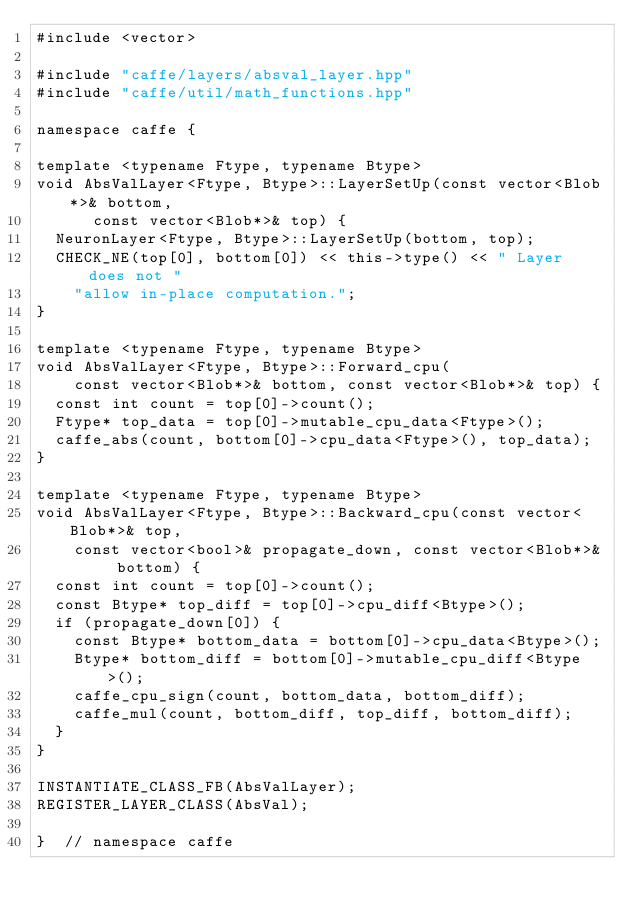Convert code to text. <code><loc_0><loc_0><loc_500><loc_500><_C++_>#include <vector>

#include "caffe/layers/absval_layer.hpp"
#include "caffe/util/math_functions.hpp"

namespace caffe {

template <typename Ftype, typename Btype>
void AbsValLayer<Ftype, Btype>::LayerSetUp(const vector<Blob*>& bottom,
      const vector<Blob*>& top) {
  NeuronLayer<Ftype, Btype>::LayerSetUp(bottom, top);
  CHECK_NE(top[0], bottom[0]) << this->type() << " Layer does not "
    "allow in-place computation.";
}

template <typename Ftype, typename Btype>
void AbsValLayer<Ftype, Btype>::Forward_cpu(
    const vector<Blob*>& bottom, const vector<Blob*>& top) {
  const int count = top[0]->count();
  Ftype* top_data = top[0]->mutable_cpu_data<Ftype>();
  caffe_abs(count, bottom[0]->cpu_data<Ftype>(), top_data);
}

template <typename Ftype, typename Btype>
void AbsValLayer<Ftype, Btype>::Backward_cpu(const vector<Blob*>& top,
    const vector<bool>& propagate_down, const vector<Blob*>& bottom) {
  const int count = top[0]->count();
  const Btype* top_diff = top[0]->cpu_diff<Btype>();
  if (propagate_down[0]) {
    const Btype* bottom_data = bottom[0]->cpu_data<Btype>();
    Btype* bottom_diff = bottom[0]->mutable_cpu_diff<Btype>();
    caffe_cpu_sign(count, bottom_data, bottom_diff);
    caffe_mul(count, bottom_diff, top_diff, bottom_diff);
  }
}

INSTANTIATE_CLASS_FB(AbsValLayer);
REGISTER_LAYER_CLASS(AbsVal);

}  // namespace caffe
</code> 